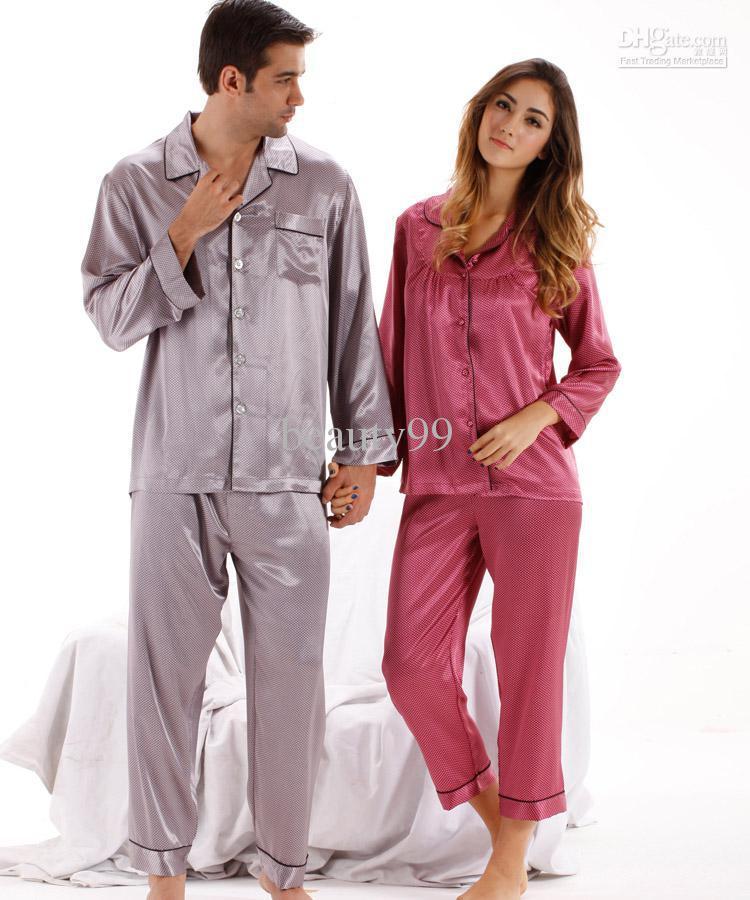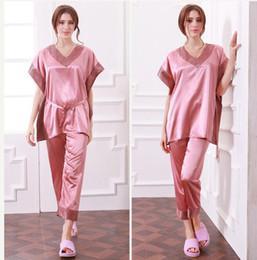The first image is the image on the left, the second image is the image on the right. Examine the images to the left and right. Is the description "One image shows a model wearing a sleeved open-front top over a lace-trimmed garment with spaghetti straps." accurate? Answer yes or no. No. The first image is the image on the left, the second image is the image on the right. Examine the images to the left and right. Is the description "A pajama set worn by a woman in one image is made with a silky fabric with button-down long sleeve shirt, with cuffs on both the shirt sleeves and pant legs." accurate? Answer yes or no. Yes. 